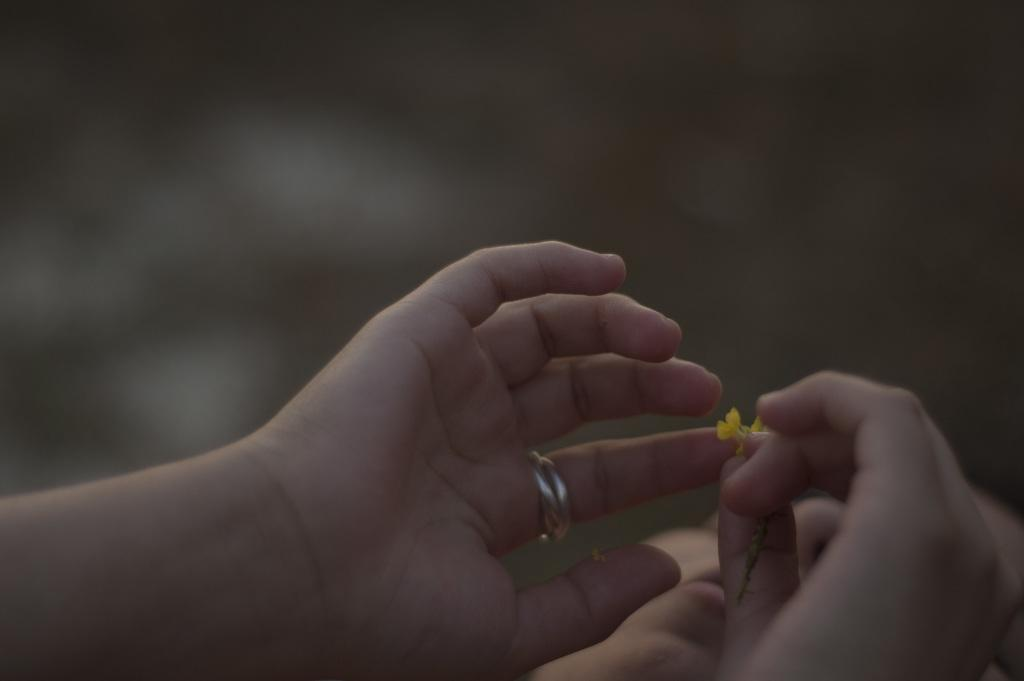Who or what is the main subject in the image? There is a person in the image. What is the person holding in the image? The person is holding a flower. What type of accessory is the person wearing? The person is wearing a finger ring. Can you describe the background of the image? The background of the image is blurry. How many ducks are visible in the image? There are no ducks present in the image. What is the arm of the person doing in the image? The provided facts do not mention the person's arm or its actions, so we cannot answer this question definitively. 